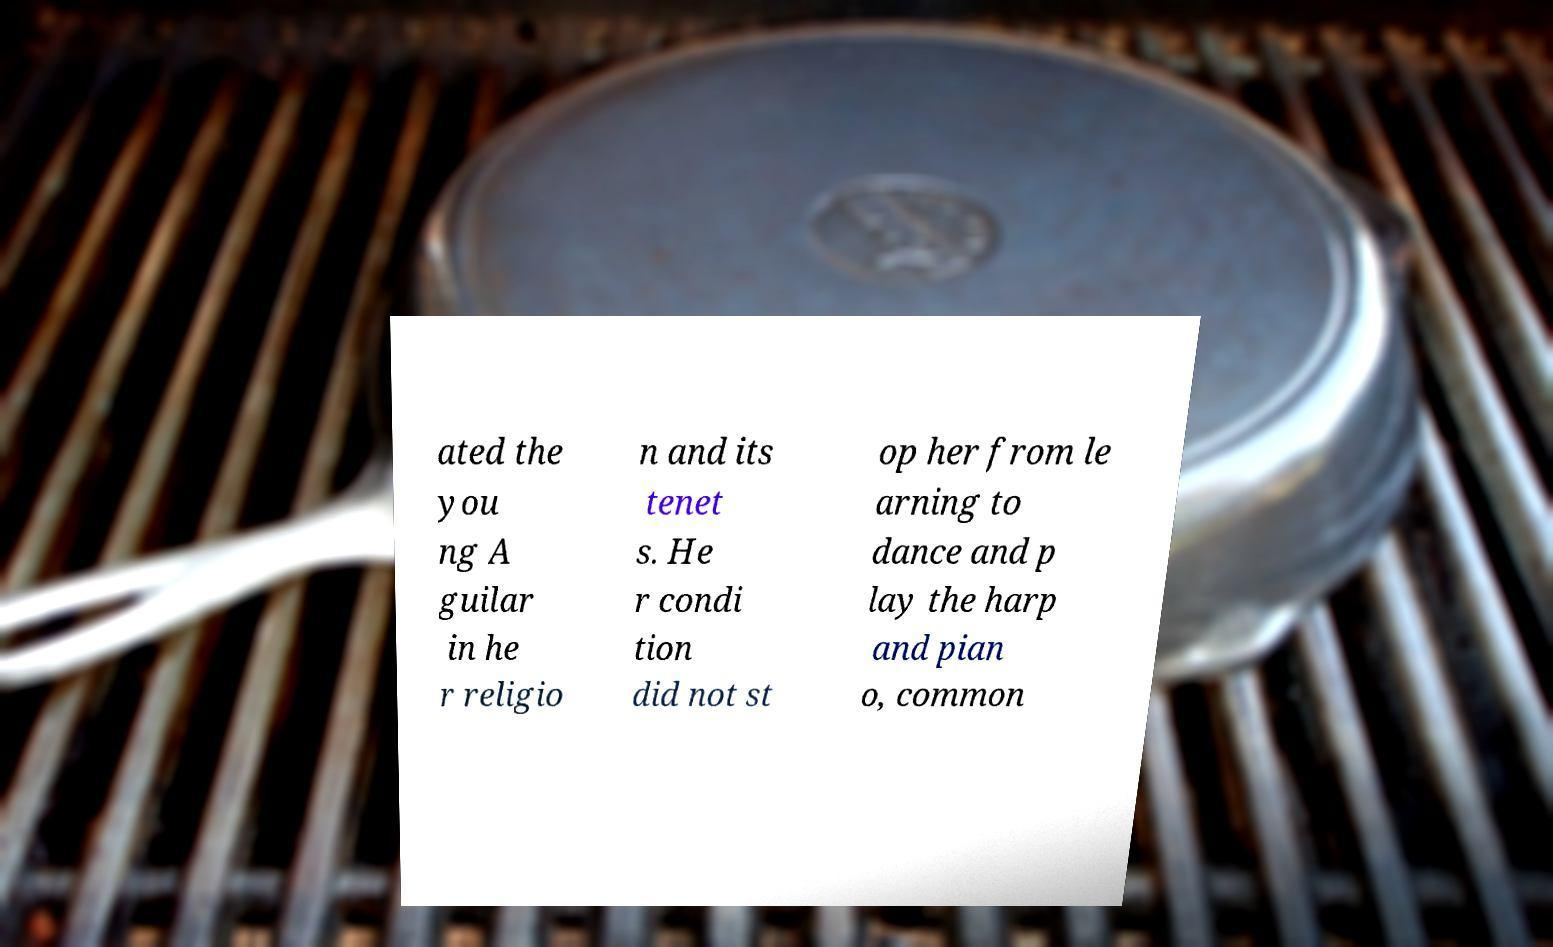Please identify and transcribe the text found in this image. ated the you ng A guilar in he r religio n and its tenet s. He r condi tion did not st op her from le arning to dance and p lay the harp and pian o, common 